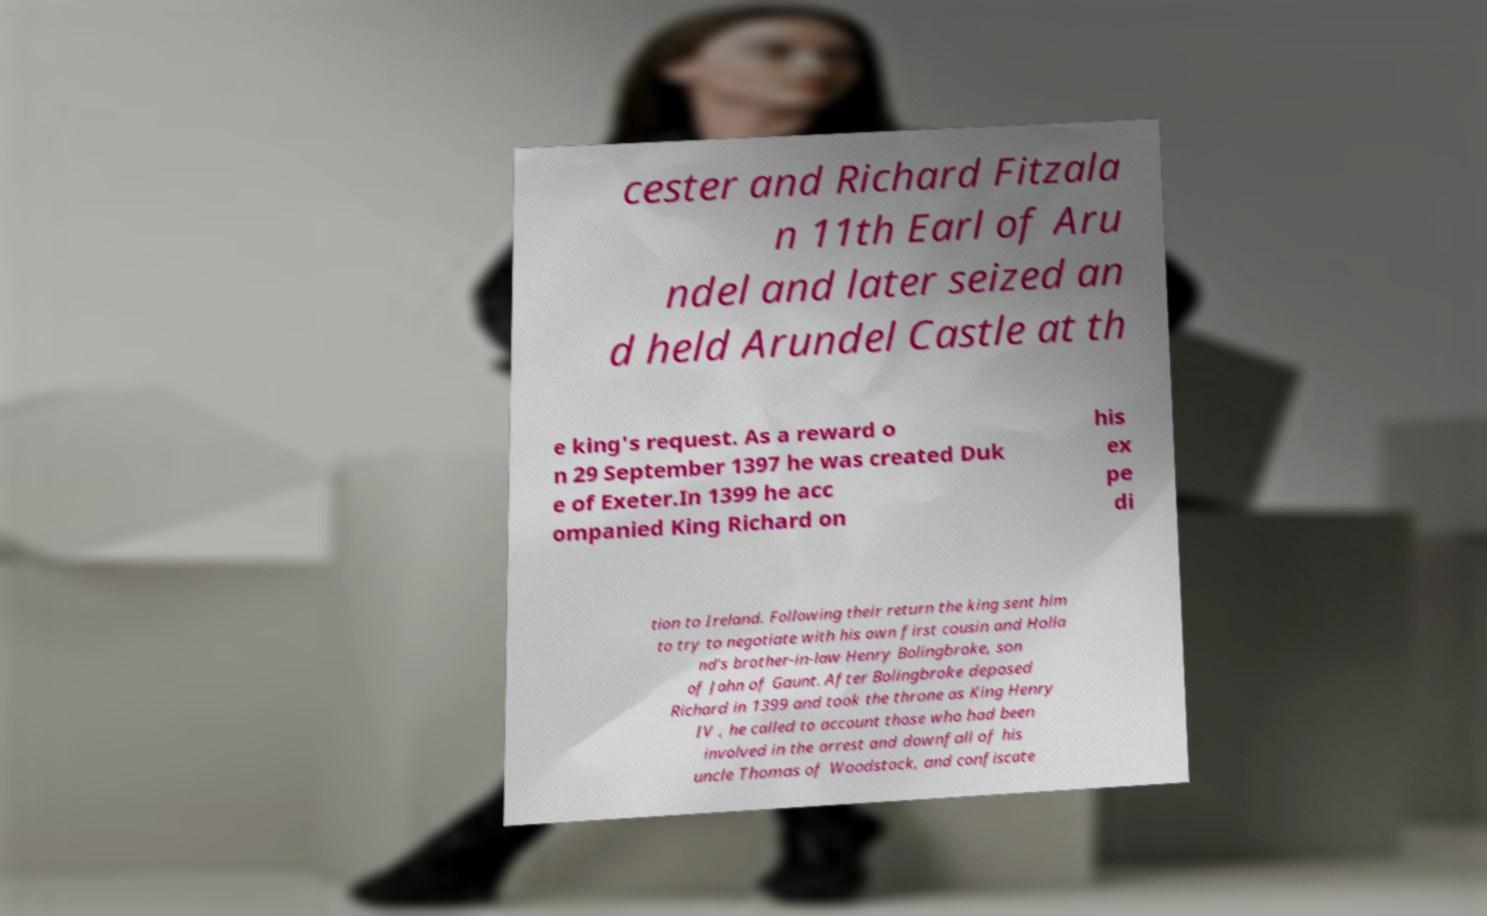What messages or text are displayed in this image? I need them in a readable, typed format. cester and Richard Fitzala n 11th Earl of Aru ndel and later seized an d held Arundel Castle at th e king's request. As a reward o n 29 September 1397 he was created Duk e of Exeter.In 1399 he acc ompanied King Richard on his ex pe di tion to Ireland. Following their return the king sent him to try to negotiate with his own first cousin and Holla nd's brother-in-law Henry Bolingbroke, son of John of Gaunt. After Bolingbroke deposed Richard in 1399 and took the throne as King Henry IV , he called to account those who had been involved in the arrest and downfall of his uncle Thomas of Woodstock, and confiscate 